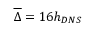Convert formula to latex. <formula><loc_0><loc_0><loc_500><loc_500>\overline { \Delta } = 1 6 h _ { D N S }</formula> 